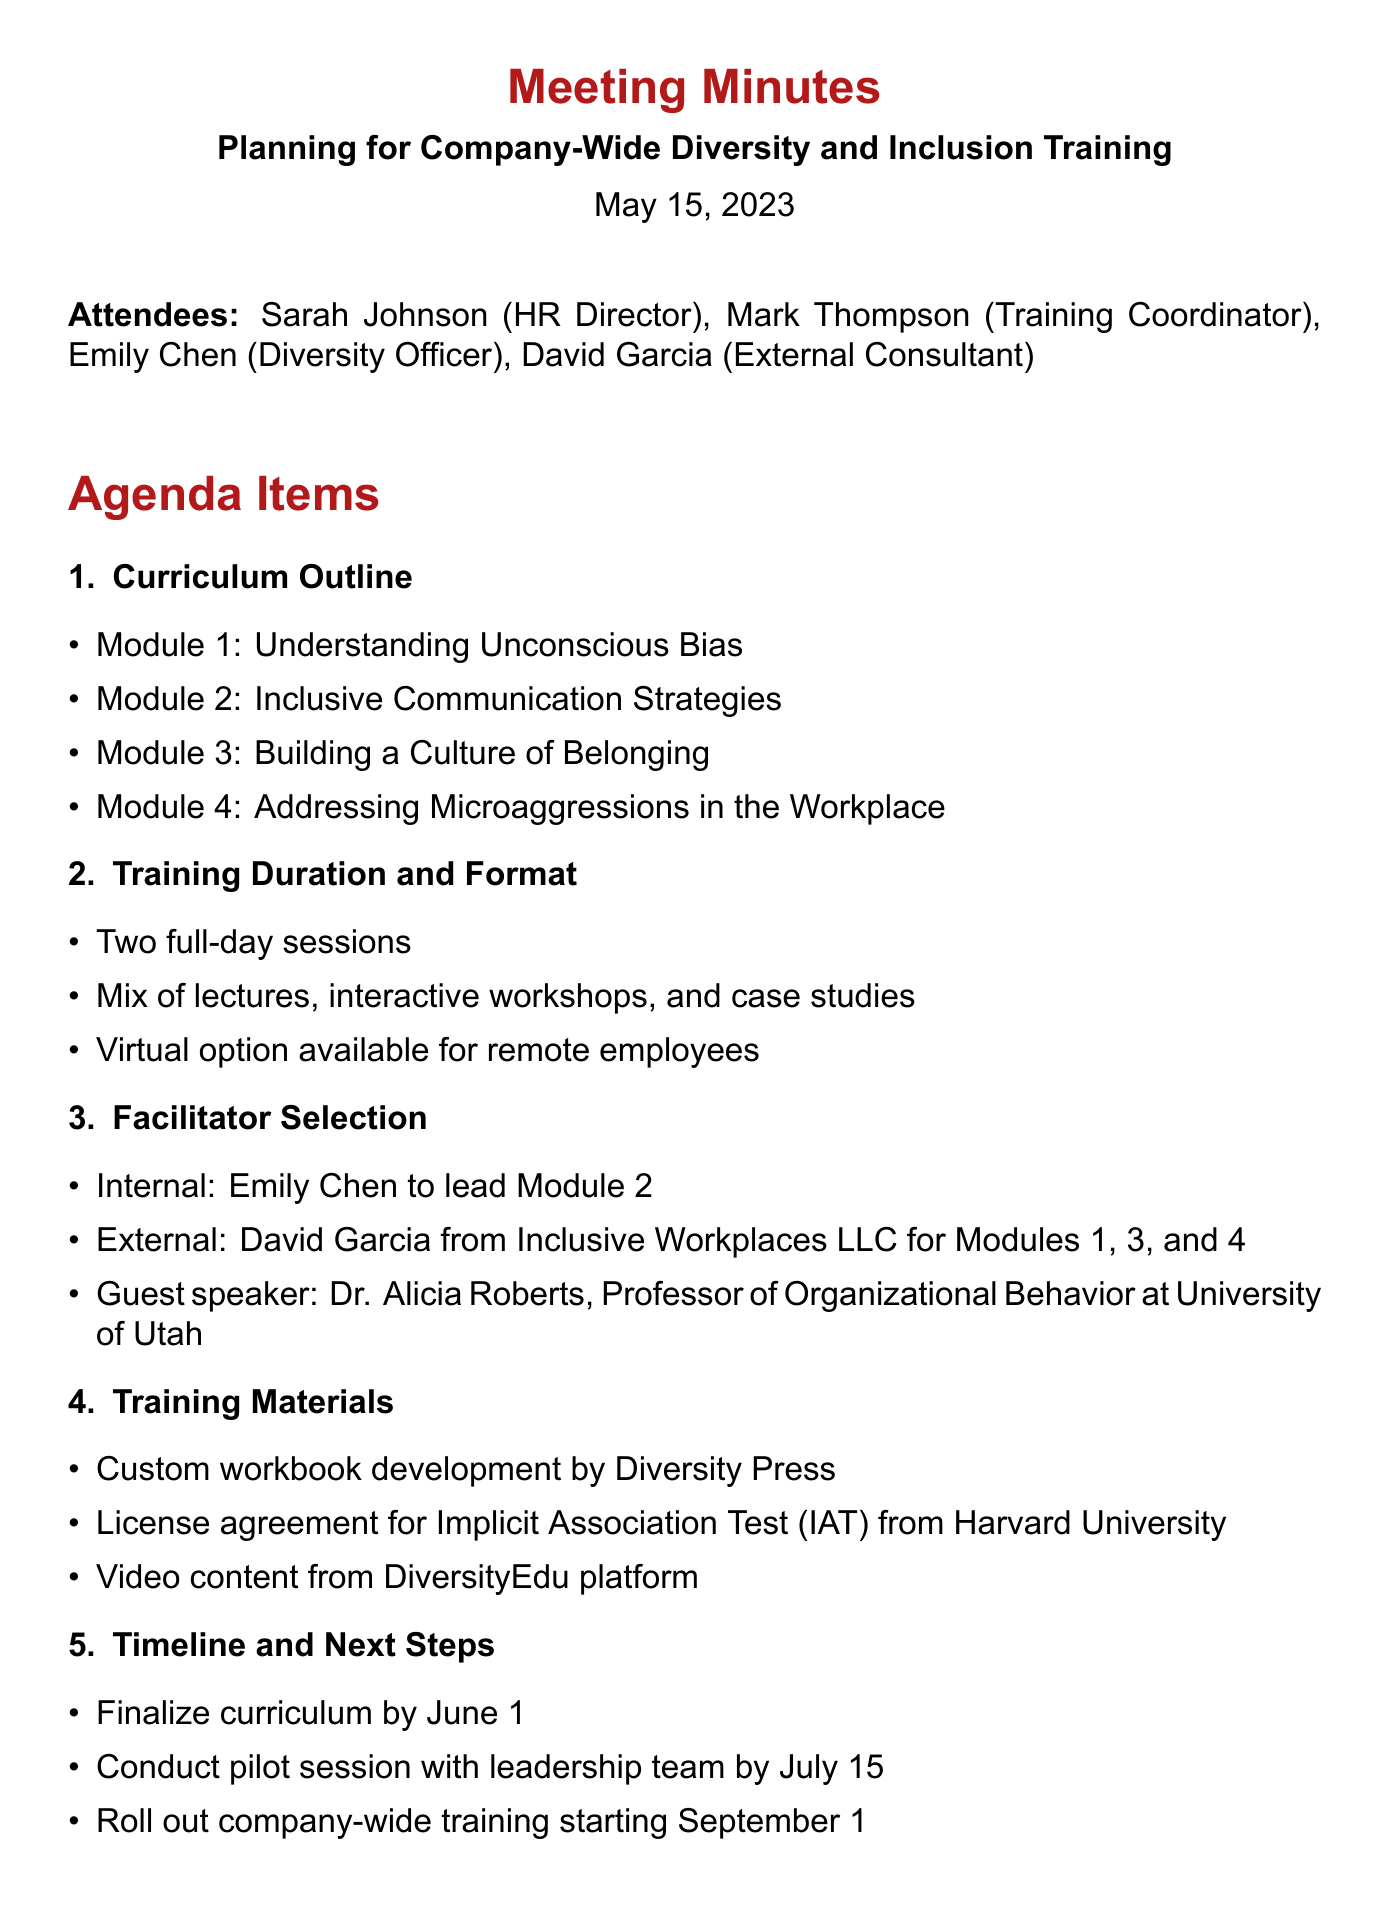What is the date of the meeting? The date of the meeting is listed in the document header as May 15, 2023.
Answer: May 15, 2023 Who is the training coordinator? The name of the training coordinator is mentioned in the list of attendees, which states Mark Thompson's role.
Answer: Mark Thompson What is the first module of the training curriculum? The first module is listed under the Curriculum Outline section, which specifies "Understanding Unconscious Bias".
Answer: Understanding Unconscious Bias How many full-day sessions are planned for training? The document indicates that there will be two full-day sessions in the Training Duration and Format section.
Answer: Two Who will lead Module 2? The facilitator for Module 2 is specified as Emily Chen in the Facilitator Selection section.
Answer: Emily Chen What will be sent by June 15? The action item specifies that Sarah will send a company-wide announcement by June 15.
Answer: Company-wide announcement What is the timeline for finalizing the curriculum? The document states the curriculum needs to be finalized by June 1, which is noted in the Timeline and Next Steps section.
Answer: June 1 Which external consultant will be involved? The document mentions David Garcia from Inclusive Workplaces LLC as the external consultant for specific modules.
Answer: David Garcia When will the company-wide training roll-out start? The Timeline and Next Steps section specifies that the roll-out will start on September 1.
Answer: September 1 